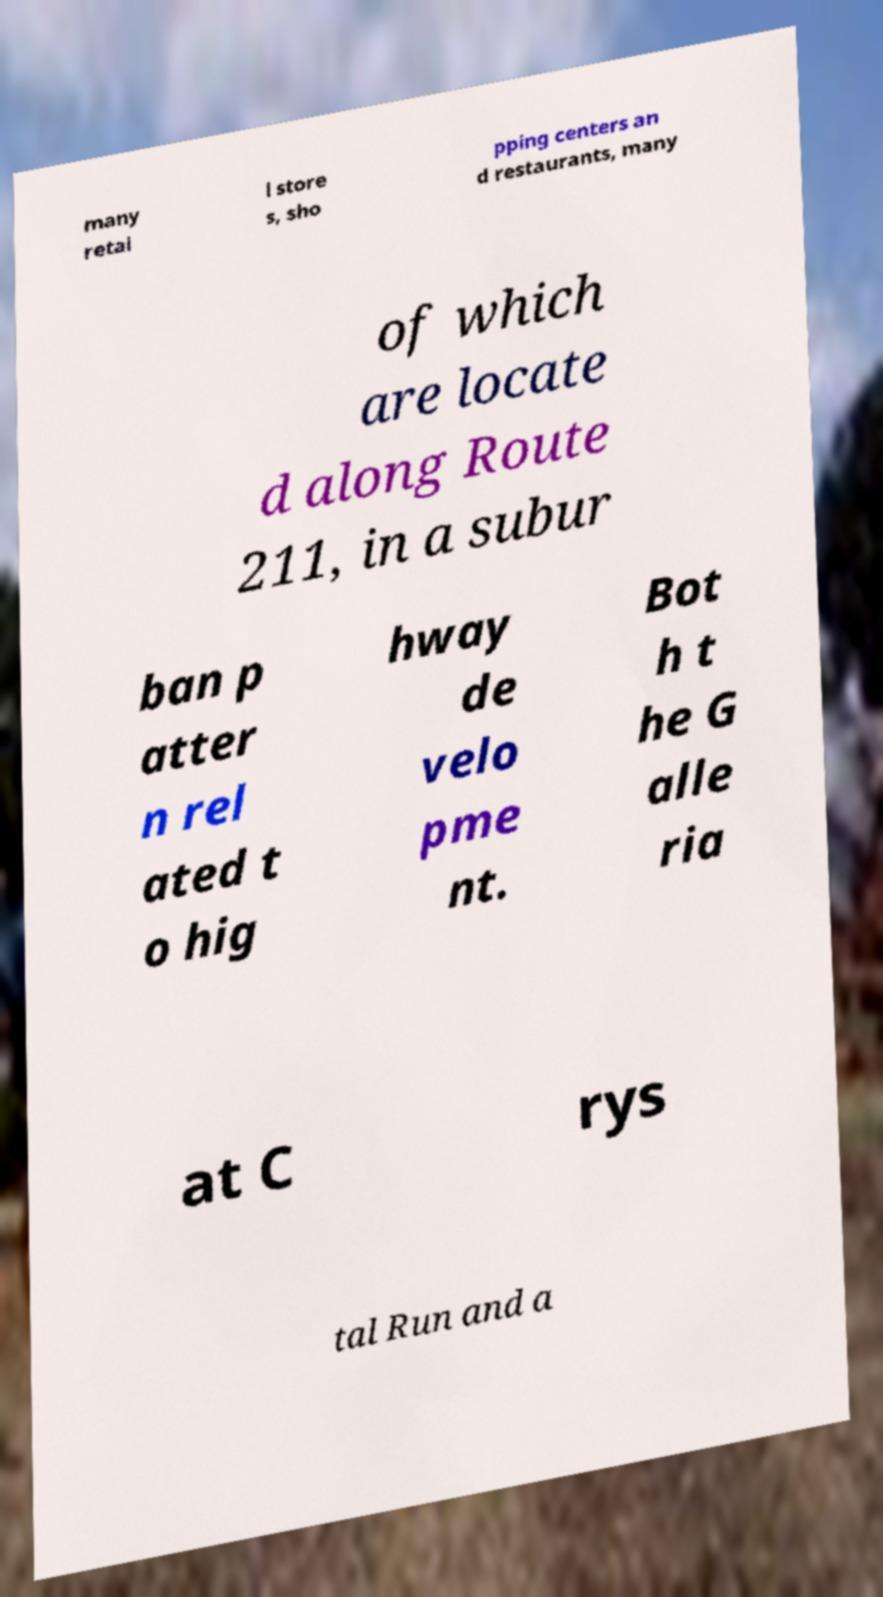Can you accurately transcribe the text from the provided image for me? many retai l store s, sho pping centers an d restaurants, many of which are locate d along Route 211, in a subur ban p atter n rel ated t o hig hway de velo pme nt. Bot h t he G alle ria at C rys tal Run and a 